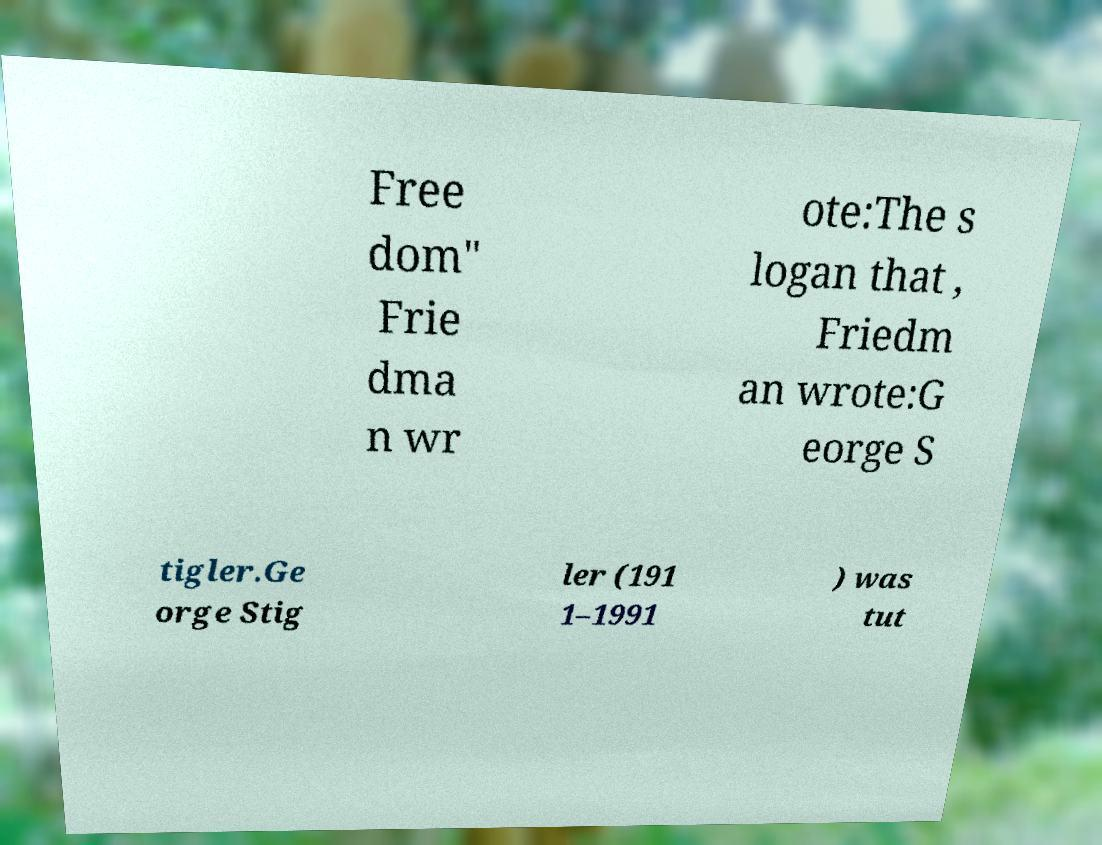Could you assist in decoding the text presented in this image and type it out clearly? Free dom" Frie dma n wr ote:The s logan that , Friedm an wrote:G eorge S tigler.Ge orge Stig ler (191 1–1991 ) was tut 